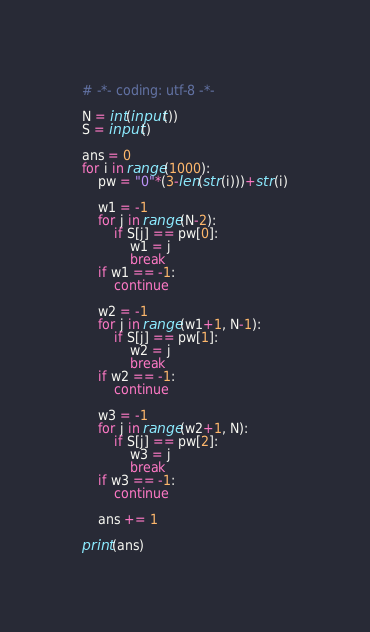<code> <loc_0><loc_0><loc_500><loc_500><_Python_># -*- coding: utf-8 -*-
 
N = int(input())
S = input()
 
ans = 0
for i in range(1000):
    pw = "0"*(3-len(str(i)))+str(i)
 
    w1 = -1
    for j in range(N-2):
        if S[j] == pw[0]:
            w1 = j
            break
    if w1 == -1:
        continue
 
    w2 = -1
    for j in range(w1+1, N-1):
        if S[j] == pw[1]:
            w2 = j
            break
    if w2 == -1:
        continue
 
    w3 = -1
    for j in range(w2+1, N):
        if S[j] == pw[2]:
            w3 = j
            break
    if w3 == -1:
        continue
 
    ans += 1
 
print(ans)</code> 